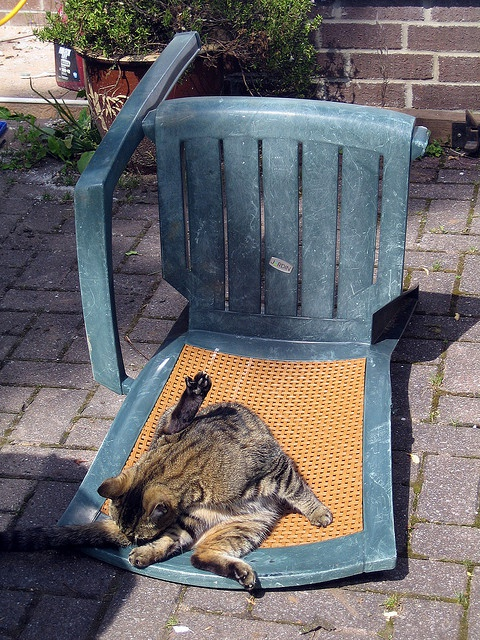Describe the objects in this image and their specific colors. I can see chair in tan, gray, and black tones, cat in tan, black, gray, and darkgray tones, and potted plant in tan, black, gray, darkgreen, and maroon tones in this image. 